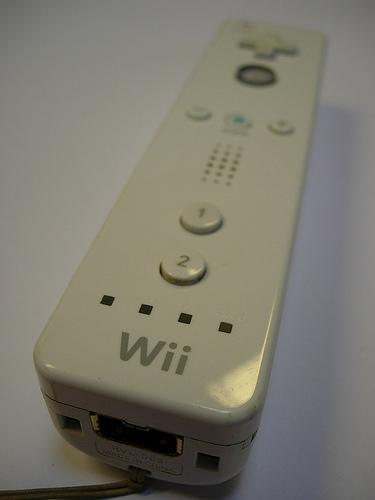Question: why was this photo taken?
Choices:
A. To show the controller.
B. To show the girl.
C. To show the clouds.
D. To show the cat.
Answer with the letter. Answer: A Question: what numbers are in the controller?
Choices:
A. Two and three.
B. One and two.
C. Three and four.
D. Four and two.
Answer with the letter. Answer: B Question: what is this a photo of?
Choices:
A. A bird.
B. A kitten.
C. A Wii controller.
D. A sofa.
Answer with the letter. Answer: C Question: who took this photo?
Choices:
A. The owner.
B. A professional photographer.
C. A little girl.
D. A tourist.
Answer with the letter. Answer: A Question: where was this photo taken?
Choices:
A. Outside the house.
B. In a restaurant.
C. At the beach.
D. Inside the house.
Answer with the letter. Answer: D 